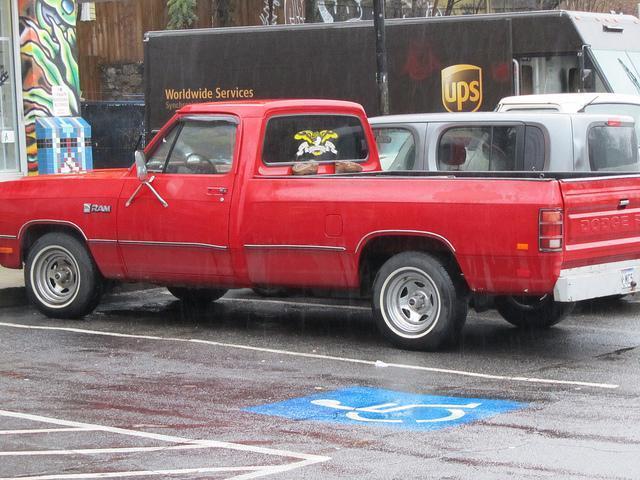How many cars are there?
Give a very brief answer. 2. How many trucks are visible?
Give a very brief answer. 3. 